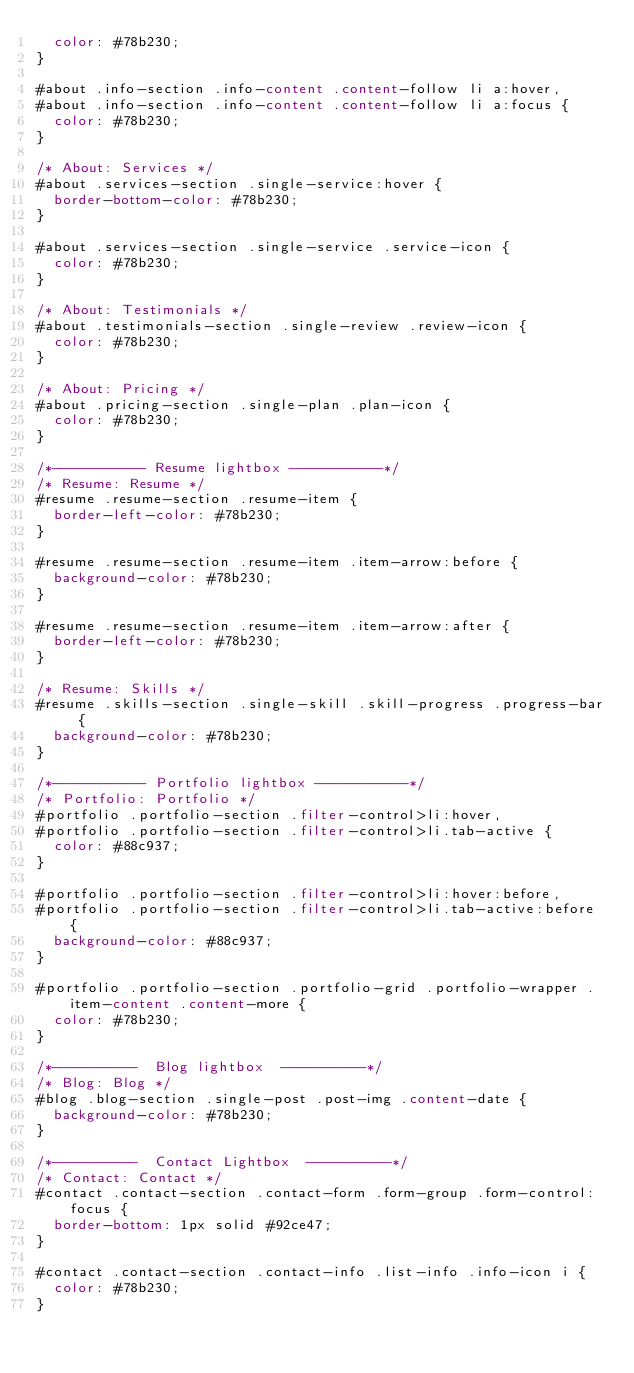<code> <loc_0><loc_0><loc_500><loc_500><_CSS_>  color: #78b230;
}

#about .info-section .info-content .content-follow li a:hover,
#about .info-section .info-content .content-follow li a:focus {
  color: #78b230;
}

/* About: Services */
#about .services-section .single-service:hover {
  border-bottom-color: #78b230;
}

#about .services-section .single-service .service-icon {
  color: #78b230;
}

/* About: Testimonials */
#about .testimonials-section .single-review .review-icon {
  color: #78b230;
}

/* About: Pricing */
#about .pricing-section .single-plan .plan-icon {
  color: #78b230;
}

/*----------- Resume lightbox -----------*/
/* Resume: Resume */
#resume .resume-section .resume-item {
  border-left-color: #78b230;
}

#resume .resume-section .resume-item .item-arrow:before {
  background-color: #78b230;
}

#resume .resume-section .resume-item .item-arrow:after {
  border-left-color: #78b230;
}

/* Resume: Skills */
#resume .skills-section .single-skill .skill-progress .progress-bar {
  background-color: #78b230;
}

/*----------- Portfolio lightbox -----------*/
/* Portfolio: Portfolio */
#portfolio .portfolio-section .filter-control>li:hover,
#portfolio .portfolio-section .filter-control>li.tab-active {
  color: #88c937;
}

#portfolio .portfolio-section .filter-control>li:hover:before,
#portfolio .portfolio-section .filter-control>li.tab-active:before {
  background-color: #88c937;
}

#portfolio .portfolio-section .portfolio-grid .portfolio-wrapper .item-content .content-more {
  color: #78b230;
}

/*----------  Blog lightbox  ----------*/
/* Blog: Blog */
#blog .blog-section .single-post .post-img .content-date {
  background-color: #78b230;
}

/*----------  Contact Lightbox  ----------*/
/* Contact: Contact */
#contact .contact-section .contact-form .form-group .form-control:focus {
  border-bottom: 1px solid #92ce47;
}

#contact .contact-section .contact-info .list-info .info-icon i {
  color: #78b230;
}</code> 